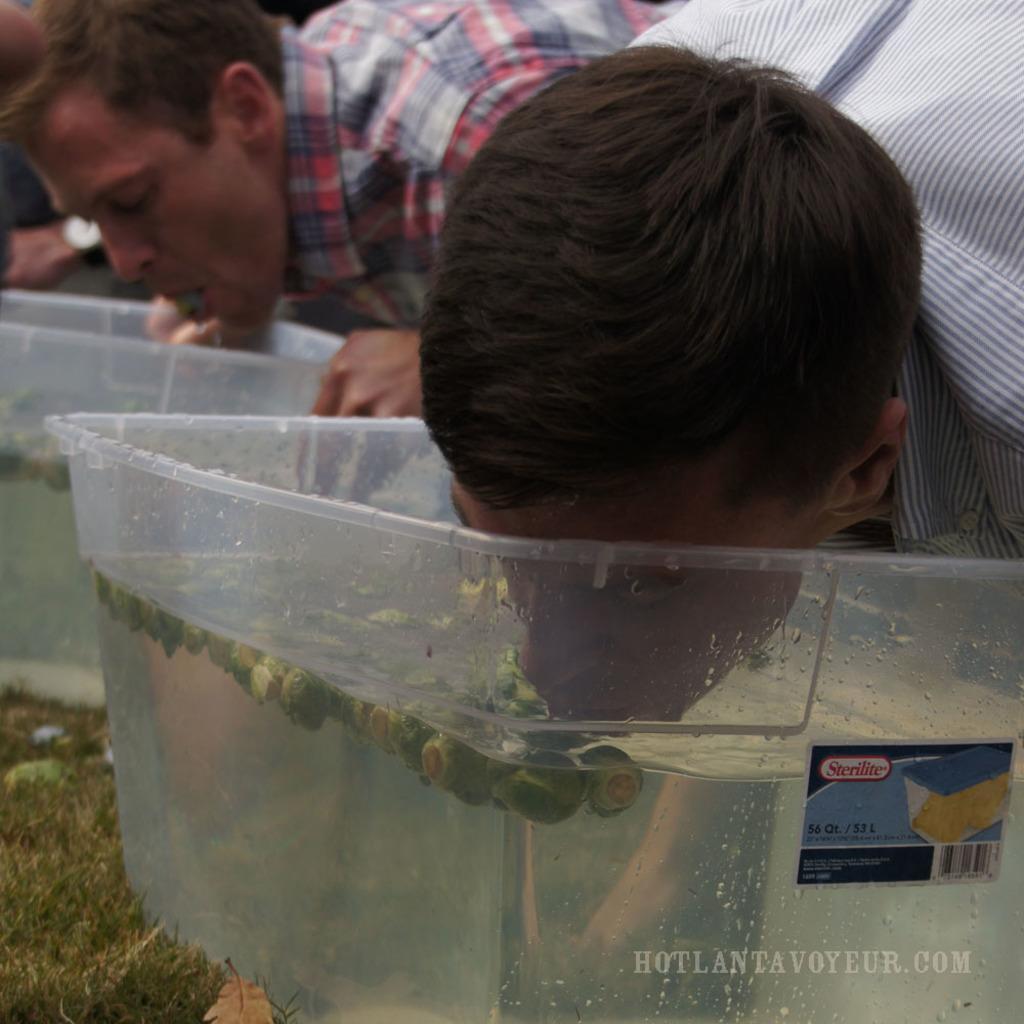Could you give a brief overview of what you see in this image? In this image there are some persons standing as we can see at top right side of this image and there are two tubs are kept at bottom of this image and there is some text written at bottom right corner of this image. 